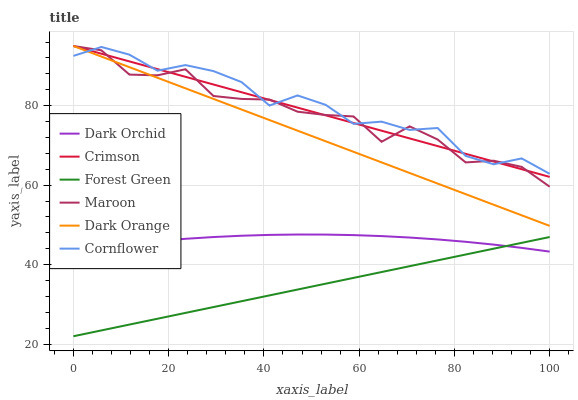Does Forest Green have the minimum area under the curve?
Answer yes or no. Yes. Does Cornflower have the maximum area under the curve?
Answer yes or no. Yes. Does Maroon have the minimum area under the curve?
Answer yes or no. No. Does Maroon have the maximum area under the curve?
Answer yes or no. No. Is Crimson the smoothest?
Answer yes or no. Yes. Is Maroon the roughest?
Answer yes or no. Yes. Is Cornflower the smoothest?
Answer yes or no. No. Is Cornflower the roughest?
Answer yes or no. No. Does Maroon have the lowest value?
Answer yes or no. No. Does Crimson have the highest value?
Answer yes or no. Yes. Does Cornflower have the highest value?
Answer yes or no. No. Is Dark Orchid less than Crimson?
Answer yes or no. Yes. Is Crimson greater than Dark Orchid?
Answer yes or no. Yes. Does Dark Orange intersect Cornflower?
Answer yes or no. Yes. Is Dark Orange less than Cornflower?
Answer yes or no. No. Is Dark Orange greater than Cornflower?
Answer yes or no. No. Does Dark Orchid intersect Crimson?
Answer yes or no. No. 